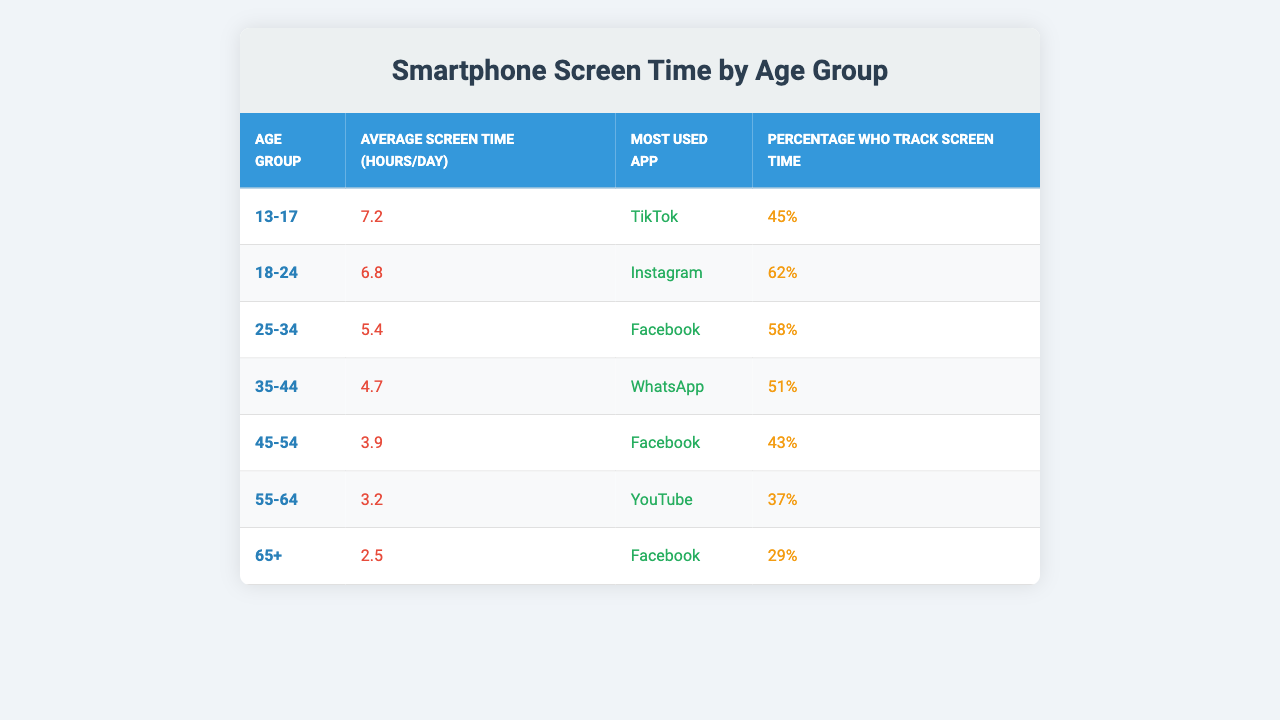What's the average screen time for the 13-17 age group? The table states the average screen time for the 13-17 age group is listed directly as 7.2 hours per day.
Answer: 7.2 hours/day Which age group has the highest average screen time? By looking at the average screen time values in the table, the 13-17 age group has the highest average at 7.2 hours per day, compared to all other age groups.
Answer: 13-17 What app is most commonly used by the 25-34 age group? The table clearly shows that Facebook is the most used app for the 25-34 age group.
Answer: Facebook What percentage of the 65+ age group tracks their screen time? The table indicates that 29% of the 65+ age group track their screen time.
Answer: 29% What is the difference in average screen time between the 18-24 and 55-64 age groups? From the table, the 18-24 age group has an average screen time of 6.8 hours/day, and the 55-64 age group has an average of 3.2 hours/day. The difference is 6.8 - 3.2 = 3.6 hours.
Answer: 3.6 hours What is the average screen time across all age groups? To find the average screen time, sum the average screen times: 7.2 + 6.8 + 5.4 + 4.7 + 3.9 + 3.2 + 2.5 = 33.7 hours, then divide by 7 (the number of groups) giving 33.7 / 7 = 4.81 hours/day.
Answer: 4.81 hours/day True or False: The most used app for the 35-44 age group is Instagram. The table states that WhatsApp is the most used app for the 35-44 age group, so the statement is false.
Answer: False Which age group tracks their screen time the least? By comparing the percentages of those who track their screen time, the 65+ age group has the lowest percentage at 29%.
Answer: 65+ What is the total percentage of people across all age groups who track their screen time? To find the total percentage, add up the percentages: 45 + 62 + 58 + 51 + 43 + 37 + 29 = 325%. Now, calculate the average: 325% / 7 = 46.43%.
Answer: 46.43% In which age group is TikTok the most used app? The table specifies that TikTok is the most used app for the 13-17 age group.
Answer: 13-17 